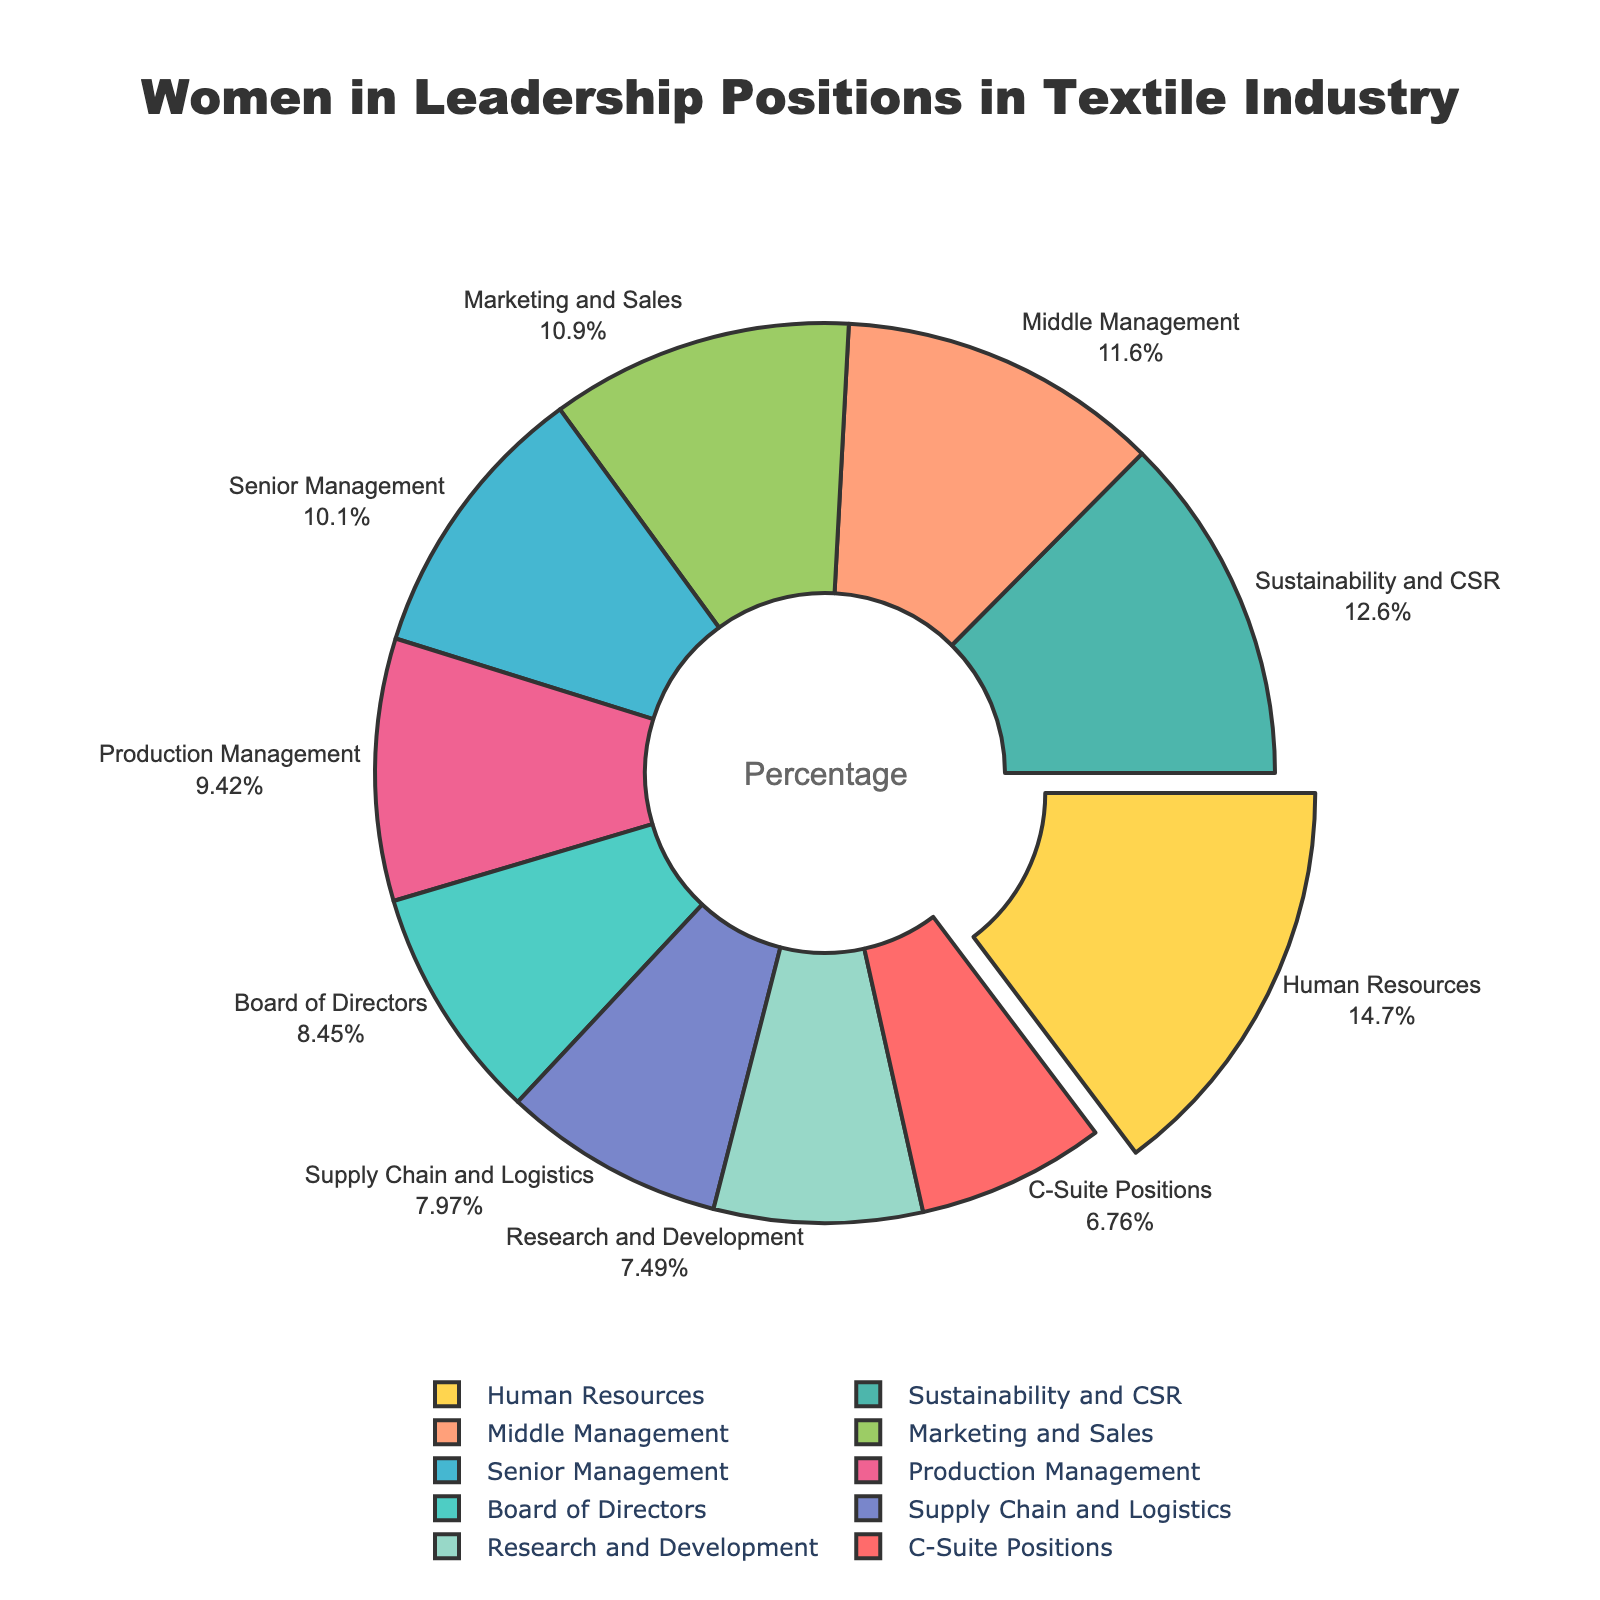Which leadership position category has the highest percentage of women? To identify the category with the highest percentage of women, we look for the slice of the pie chart that is the largest. The largest slice corresponds to the "Human Resources" category.
Answer: Human Resources Which category has the lowest percentage of women in leadership positions? To find the category with the lowest percentage, we look for the smallest slice of the pie chart. The smallest slice represents the "C-Suite Positions" category.
Answer: C-Suite Positions What is the percentage difference between women in Marketing and Sales and women in Research and Development? First, find the percentages for "Marketing and Sales" (45%) and "Research and Development" (31%). Then calculate the difference: 45% - 31% = 14%.
Answer: 14% How many categories have a percentage of women in leadership above 40%? Identify the slices representing categories with percentages above 40%. These categories are "Senior Management" (42%), "Middle Management" (48%), "Marketing and Sales" (45%), "Human Resources" (61%), and "Sustainability and CSR" (52%). Count these categories.
Answer: 5 Which category is visually pulled out slightly compared to the others, and why might this be? The pie chart visually pulls out the slice with the highest percentage. The slice for "Human Resources" is pulled out since it has the highest percentage (61%).
Answer: Human Resources What is the sum of the percentages for "Production Management," "Supply Chain and Logistics," and "Sustainability and CSR"? Add the percentages for these categories: 39% (Production Management) + 33% (Supply Chain and Logistics) + 52% (Sustainability and CSR). The sum is 39% + 33% + 52% = 124%.
Answer: 124% Compare the percentages of women in Senior Management and Production Management. Which has a higher percentage, and by how much? Identify the percentages for "Senior Management" (42%) and "Production Management" (39%). The difference is 42% - 39% = 3%.
Answer: Senior Management, 3% What is the average percentage of women in leadership across all categories? Sum all the percentages: 28% + 35% + 42% + 48% + 31% + 39% + 33% + 45% + 61% + 52% = 414%. Divide by the number of categories (10). The average percentage is 414% / 10 = 41.4%.
Answer: 41.4% If you combined the percentages of women in "C-Suite Positions" and "Board of Directors," what would it be? Is the total more than the percentage in "Human Resources"? Add the percentages for "C-Suite Positions" (28%) and "Board of Directors" (35%): 28% + 35% = 63%. Compare it to "Human Resources" (61%). 63% is greater than 61%.
Answer: 63%, yes 